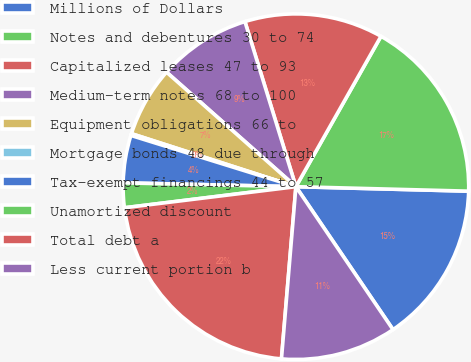<chart> <loc_0><loc_0><loc_500><loc_500><pie_chart><fcel>Millions of Dollars<fcel>Notes and debentures 30 to 74<fcel>Capitalized leases 47 to 93<fcel>Medium-term notes 68 to 100<fcel>Equipment obligations 66 to<fcel>Mortgage bonds 48 due through<fcel>Tax-exempt financings 44 to 57<fcel>Unamortized discount<fcel>Total debt a<fcel>Less current portion b<nl><fcel>15.09%<fcel>17.22%<fcel>12.96%<fcel>8.7%<fcel>6.57%<fcel>0.17%<fcel>4.44%<fcel>2.3%<fcel>21.72%<fcel>10.83%<nl></chart> 